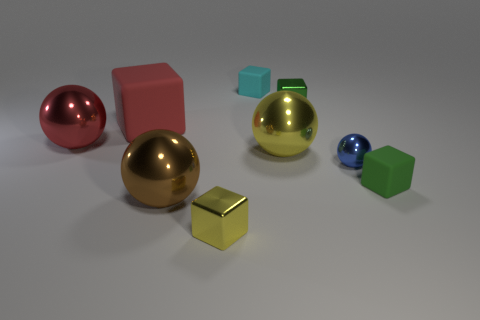Subtract all small blocks. How many blocks are left? 1 Subtract all brown balls. How many balls are left? 3 Subtract 1 spheres. How many spheres are left? 3 Subtract all spheres. How many objects are left? 5 Subtract all green cylinders. How many red balls are left? 1 Add 2 yellow metallic blocks. How many yellow metallic blocks are left? 3 Add 2 cyan matte blocks. How many cyan matte blocks exist? 3 Subtract 0 blue cylinders. How many objects are left? 9 Subtract all gray blocks. Subtract all brown spheres. How many blocks are left? 5 Subtract all red matte spheres. Subtract all big red cubes. How many objects are left? 8 